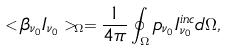Convert formula to latex. <formula><loc_0><loc_0><loc_500><loc_500>< \beta _ { \nu _ { 0 } } I _ { \nu _ { 0 } } > _ { \Omega } = \frac { 1 } { 4 \pi } \oint _ { \Omega } p _ { \nu _ { 0 } } I ^ { i n c } _ { \nu _ { 0 } } d \Omega ,</formula> 